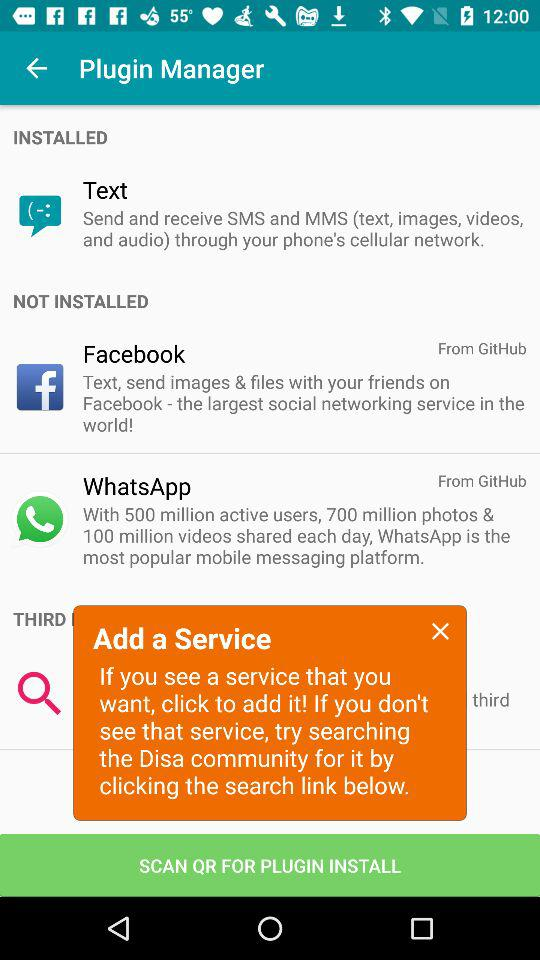Where is "Text" from?
When the provided information is insufficient, respond with <no answer>. <no answer> 